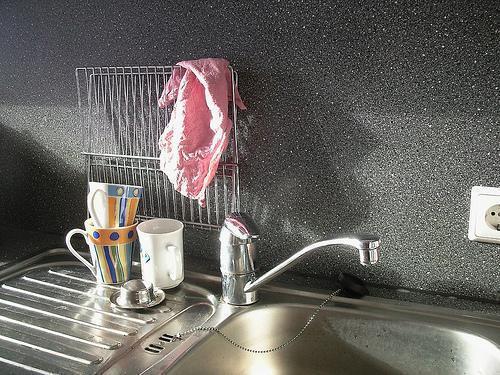How many cups are there?
Give a very brief answer. 3. 